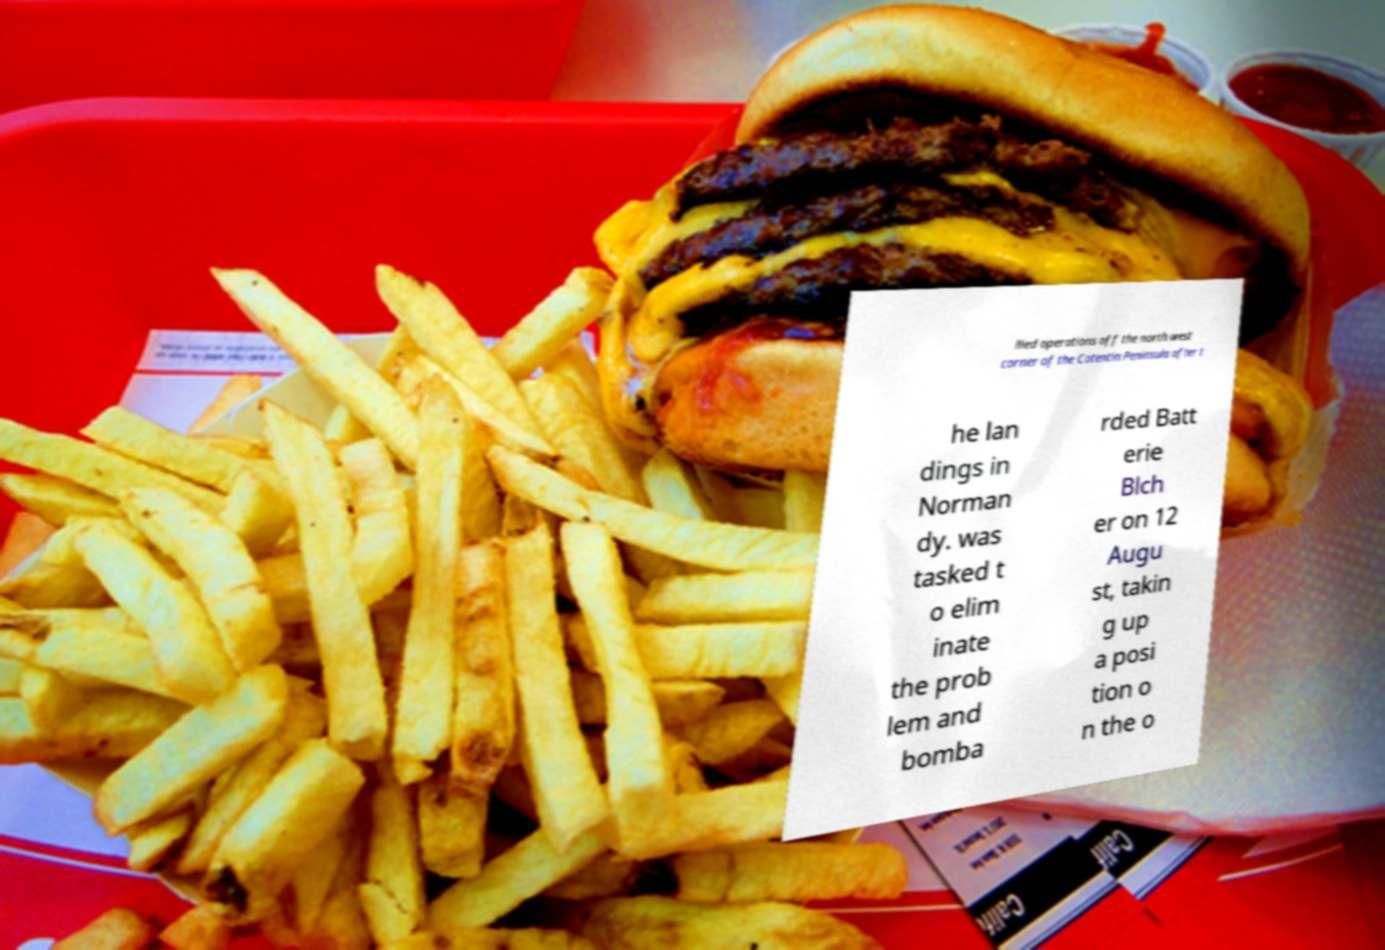For documentation purposes, I need the text within this image transcribed. Could you provide that? llied operations off the north west corner of the Cotentin Peninsula after t he lan dings in Norman dy. was tasked t o elim inate the prob lem and bomba rded Batt erie Blch er on 12 Augu st, takin g up a posi tion o n the o 